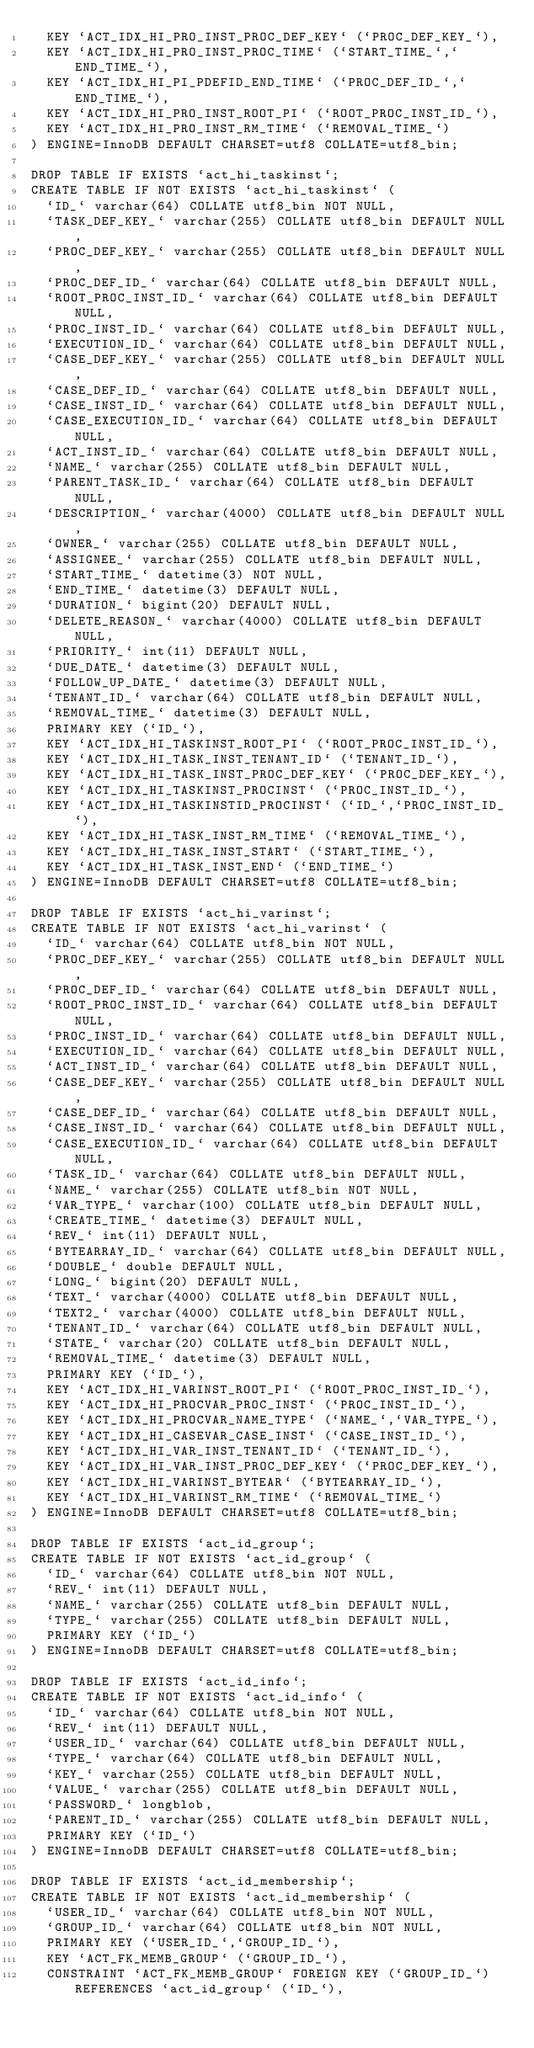<code> <loc_0><loc_0><loc_500><loc_500><_SQL_>  KEY `ACT_IDX_HI_PRO_INST_PROC_DEF_KEY` (`PROC_DEF_KEY_`),
  KEY `ACT_IDX_HI_PRO_INST_PROC_TIME` (`START_TIME_`,`END_TIME_`),
  KEY `ACT_IDX_HI_PI_PDEFID_END_TIME` (`PROC_DEF_ID_`,`END_TIME_`),
  KEY `ACT_IDX_HI_PRO_INST_ROOT_PI` (`ROOT_PROC_INST_ID_`),
  KEY `ACT_IDX_HI_PRO_INST_RM_TIME` (`REMOVAL_TIME_`)
) ENGINE=InnoDB DEFAULT CHARSET=utf8 COLLATE=utf8_bin;

DROP TABLE IF EXISTS `act_hi_taskinst`;
CREATE TABLE IF NOT EXISTS `act_hi_taskinst` (
  `ID_` varchar(64) COLLATE utf8_bin NOT NULL,
  `TASK_DEF_KEY_` varchar(255) COLLATE utf8_bin DEFAULT NULL,
  `PROC_DEF_KEY_` varchar(255) COLLATE utf8_bin DEFAULT NULL,
  `PROC_DEF_ID_` varchar(64) COLLATE utf8_bin DEFAULT NULL,
  `ROOT_PROC_INST_ID_` varchar(64) COLLATE utf8_bin DEFAULT NULL,
  `PROC_INST_ID_` varchar(64) COLLATE utf8_bin DEFAULT NULL,
  `EXECUTION_ID_` varchar(64) COLLATE utf8_bin DEFAULT NULL,
  `CASE_DEF_KEY_` varchar(255) COLLATE utf8_bin DEFAULT NULL,
  `CASE_DEF_ID_` varchar(64) COLLATE utf8_bin DEFAULT NULL,
  `CASE_INST_ID_` varchar(64) COLLATE utf8_bin DEFAULT NULL,
  `CASE_EXECUTION_ID_` varchar(64) COLLATE utf8_bin DEFAULT NULL,
  `ACT_INST_ID_` varchar(64) COLLATE utf8_bin DEFAULT NULL,
  `NAME_` varchar(255) COLLATE utf8_bin DEFAULT NULL,
  `PARENT_TASK_ID_` varchar(64) COLLATE utf8_bin DEFAULT NULL,
  `DESCRIPTION_` varchar(4000) COLLATE utf8_bin DEFAULT NULL,
  `OWNER_` varchar(255) COLLATE utf8_bin DEFAULT NULL,
  `ASSIGNEE_` varchar(255) COLLATE utf8_bin DEFAULT NULL,
  `START_TIME_` datetime(3) NOT NULL,
  `END_TIME_` datetime(3) DEFAULT NULL,
  `DURATION_` bigint(20) DEFAULT NULL,
  `DELETE_REASON_` varchar(4000) COLLATE utf8_bin DEFAULT NULL,
  `PRIORITY_` int(11) DEFAULT NULL,
  `DUE_DATE_` datetime(3) DEFAULT NULL,
  `FOLLOW_UP_DATE_` datetime(3) DEFAULT NULL,
  `TENANT_ID_` varchar(64) COLLATE utf8_bin DEFAULT NULL,
  `REMOVAL_TIME_` datetime(3) DEFAULT NULL,
  PRIMARY KEY (`ID_`),
  KEY `ACT_IDX_HI_TASKINST_ROOT_PI` (`ROOT_PROC_INST_ID_`),
  KEY `ACT_IDX_HI_TASK_INST_TENANT_ID` (`TENANT_ID_`),
  KEY `ACT_IDX_HI_TASK_INST_PROC_DEF_KEY` (`PROC_DEF_KEY_`),
  KEY `ACT_IDX_HI_TASKINST_PROCINST` (`PROC_INST_ID_`),
  KEY `ACT_IDX_HI_TASKINSTID_PROCINST` (`ID_`,`PROC_INST_ID_`),
  KEY `ACT_IDX_HI_TASK_INST_RM_TIME` (`REMOVAL_TIME_`),
  KEY `ACT_IDX_HI_TASK_INST_START` (`START_TIME_`),
  KEY `ACT_IDX_HI_TASK_INST_END` (`END_TIME_`)
) ENGINE=InnoDB DEFAULT CHARSET=utf8 COLLATE=utf8_bin;

DROP TABLE IF EXISTS `act_hi_varinst`;
CREATE TABLE IF NOT EXISTS `act_hi_varinst` (
  `ID_` varchar(64) COLLATE utf8_bin NOT NULL,
  `PROC_DEF_KEY_` varchar(255) COLLATE utf8_bin DEFAULT NULL,
  `PROC_DEF_ID_` varchar(64) COLLATE utf8_bin DEFAULT NULL,
  `ROOT_PROC_INST_ID_` varchar(64) COLLATE utf8_bin DEFAULT NULL,
  `PROC_INST_ID_` varchar(64) COLLATE utf8_bin DEFAULT NULL,
  `EXECUTION_ID_` varchar(64) COLLATE utf8_bin DEFAULT NULL,
  `ACT_INST_ID_` varchar(64) COLLATE utf8_bin DEFAULT NULL,
  `CASE_DEF_KEY_` varchar(255) COLLATE utf8_bin DEFAULT NULL,
  `CASE_DEF_ID_` varchar(64) COLLATE utf8_bin DEFAULT NULL,
  `CASE_INST_ID_` varchar(64) COLLATE utf8_bin DEFAULT NULL,
  `CASE_EXECUTION_ID_` varchar(64) COLLATE utf8_bin DEFAULT NULL,
  `TASK_ID_` varchar(64) COLLATE utf8_bin DEFAULT NULL,
  `NAME_` varchar(255) COLLATE utf8_bin NOT NULL,
  `VAR_TYPE_` varchar(100) COLLATE utf8_bin DEFAULT NULL,
  `CREATE_TIME_` datetime(3) DEFAULT NULL,
  `REV_` int(11) DEFAULT NULL,
  `BYTEARRAY_ID_` varchar(64) COLLATE utf8_bin DEFAULT NULL,
  `DOUBLE_` double DEFAULT NULL,
  `LONG_` bigint(20) DEFAULT NULL,
  `TEXT_` varchar(4000) COLLATE utf8_bin DEFAULT NULL,
  `TEXT2_` varchar(4000) COLLATE utf8_bin DEFAULT NULL,
  `TENANT_ID_` varchar(64) COLLATE utf8_bin DEFAULT NULL,
  `STATE_` varchar(20) COLLATE utf8_bin DEFAULT NULL,
  `REMOVAL_TIME_` datetime(3) DEFAULT NULL,
  PRIMARY KEY (`ID_`),
  KEY `ACT_IDX_HI_VARINST_ROOT_PI` (`ROOT_PROC_INST_ID_`),
  KEY `ACT_IDX_HI_PROCVAR_PROC_INST` (`PROC_INST_ID_`),
  KEY `ACT_IDX_HI_PROCVAR_NAME_TYPE` (`NAME_`,`VAR_TYPE_`),
  KEY `ACT_IDX_HI_CASEVAR_CASE_INST` (`CASE_INST_ID_`),
  KEY `ACT_IDX_HI_VAR_INST_TENANT_ID` (`TENANT_ID_`),
  KEY `ACT_IDX_HI_VAR_INST_PROC_DEF_KEY` (`PROC_DEF_KEY_`),
  KEY `ACT_IDX_HI_VARINST_BYTEAR` (`BYTEARRAY_ID_`),
  KEY `ACT_IDX_HI_VARINST_RM_TIME` (`REMOVAL_TIME_`)
) ENGINE=InnoDB DEFAULT CHARSET=utf8 COLLATE=utf8_bin;

DROP TABLE IF EXISTS `act_id_group`;
CREATE TABLE IF NOT EXISTS `act_id_group` (
  `ID_` varchar(64) COLLATE utf8_bin NOT NULL,
  `REV_` int(11) DEFAULT NULL,
  `NAME_` varchar(255) COLLATE utf8_bin DEFAULT NULL,
  `TYPE_` varchar(255) COLLATE utf8_bin DEFAULT NULL,
  PRIMARY KEY (`ID_`)
) ENGINE=InnoDB DEFAULT CHARSET=utf8 COLLATE=utf8_bin;

DROP TABLE IF EXISTS `act_id_info`;
CREATE TABLE IF NOT EXISTS `act_id_info` (
  `ID_` varchar(64) COLLATE utf8_bin NOT NULL,
  `REV_` int(11) DEFAULT NULL,
  `USER_ID_` varchar(64) COLLATE utf8_bin DEFAULT NULL,
  `TYPE_` varchar(64) COLLATE utf8_bin DEFAULT NULL,
  `KEY_` varchar(255) COLLATE utf8_bin DEFAULT NULL,
  `VALUE_` varchar(255) COLLATE utf8_bin DEFAULT NULL,
  `PASSWORD_` longblob,
  `PARENT_ID_` varchar(255) COLLATE utf8_bin DEFAULT NULL,
  PRIMARY KEY (`ID_`)
) ENGINE=InnoDB DEFAULT CHARSET=utf8 COLLATE=utf8_bin;

DROP TABLE IF EXISTS `act_id_membership`;
CREATE TABLE IF NOT EXISTS `act_id_membership` (
  `USER_ID_` varchar(64) COLLATE utf8_bin NOT NULL,
  `GROUP_ID_` varchar(64) COLLATE utf8_bin NOT NULL,
  PRIMARY KEY (`USER_ID_`,`GROUP_ID_`),
  KEY `ACT_FK_MEMB_GROUP` (`GROUP_ID_`),
  CONSTRAINT `ACT_FK_MEMB_GROUP` FOREIGN KEY (`GROUP_ID_`) REFERENCES `act_id_group` (`ID_`),</code> 